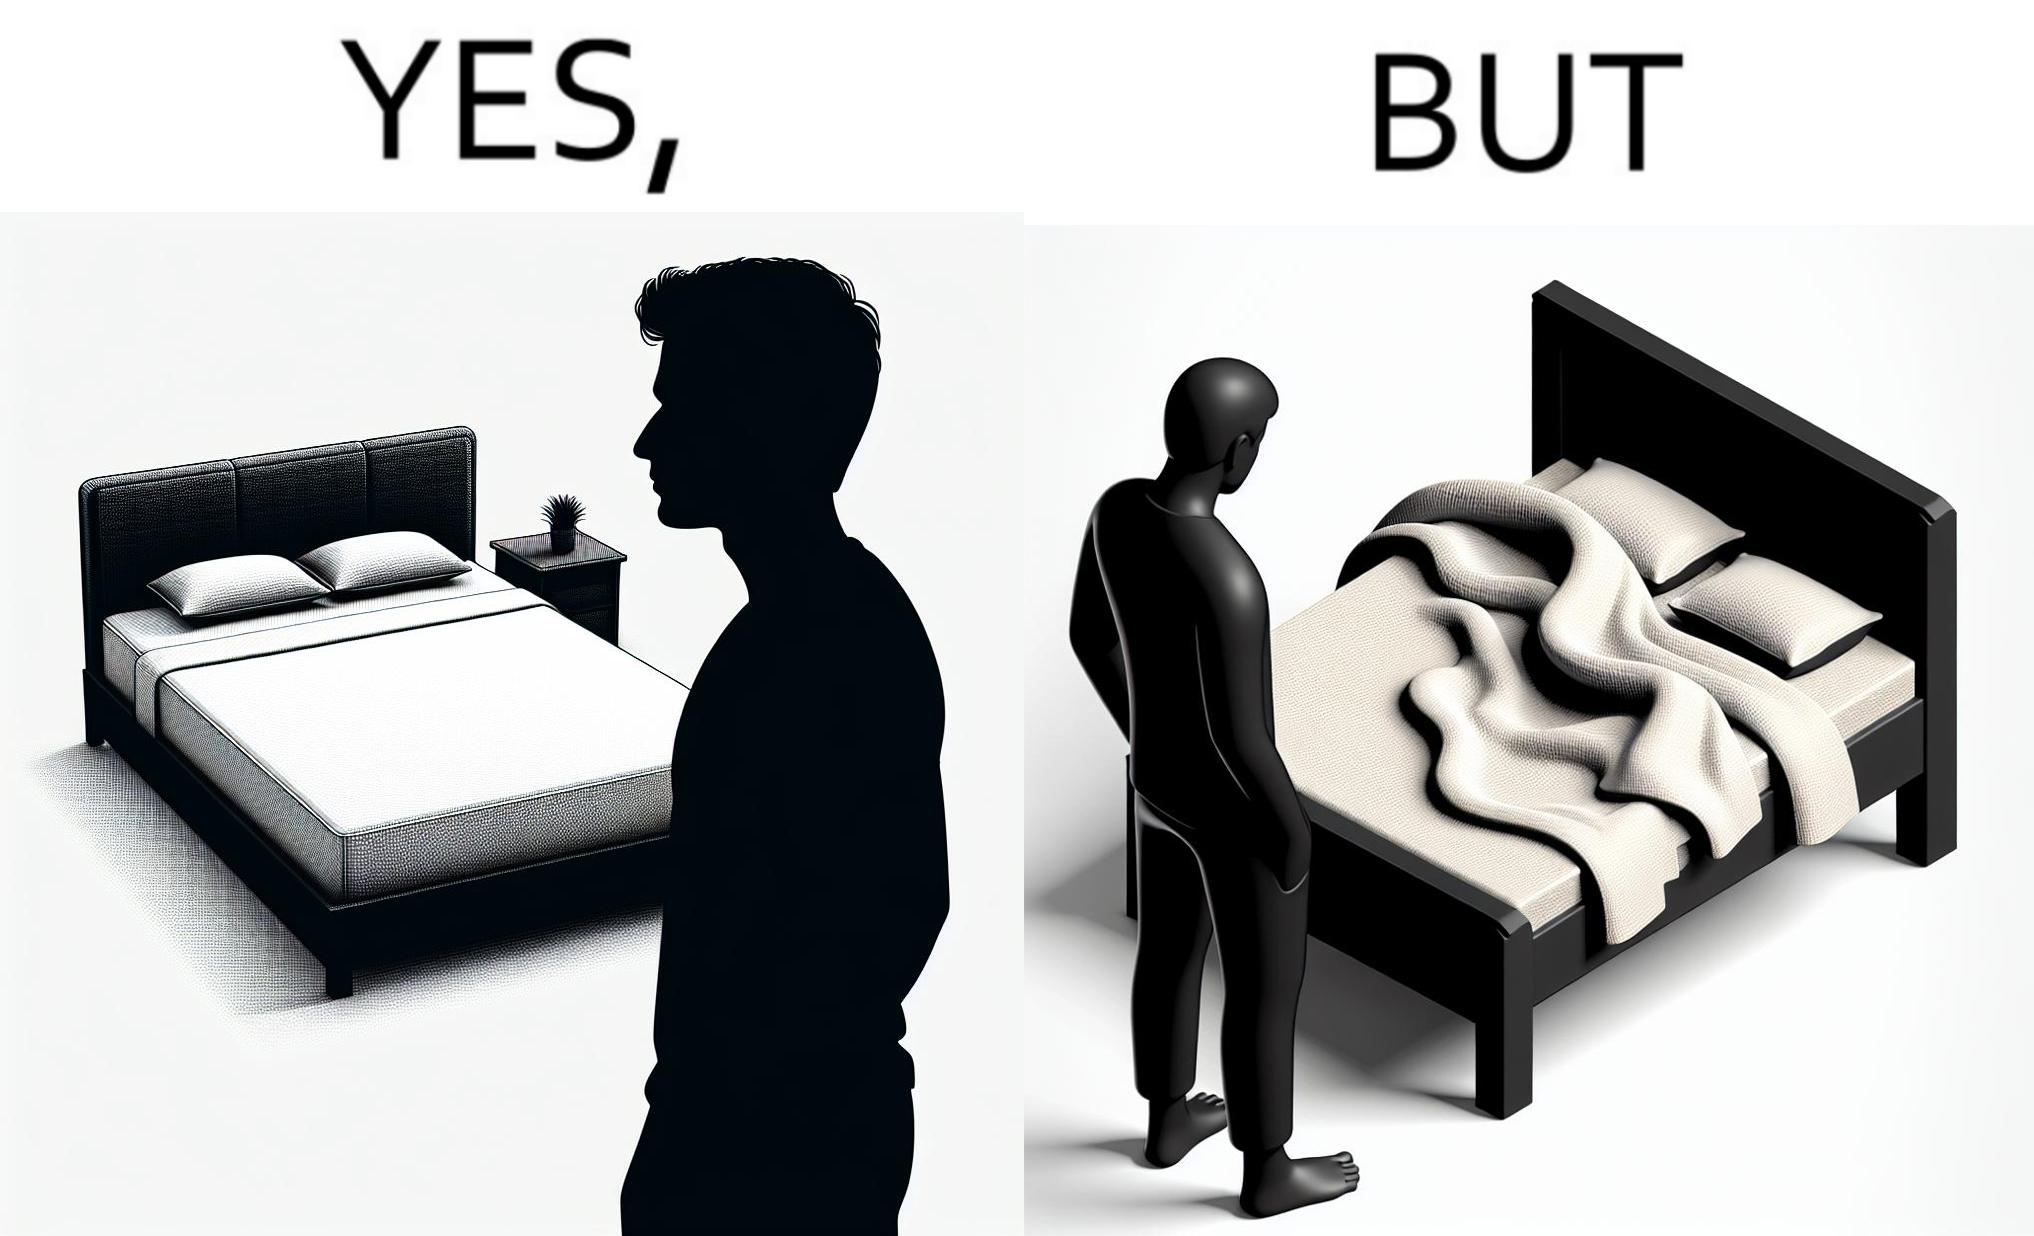Compare the left and right sides of this image. In the left part of the image: The image shows a man looking at his bed. His bed seems well made with blanket and pillow properly arranged on the mattress. In the right part of the image: The image shows a man looking at his bed. The image also shows the actual blanket inside its cover on the bed. The blanked is all twisted inside the cover and is not properly set. 